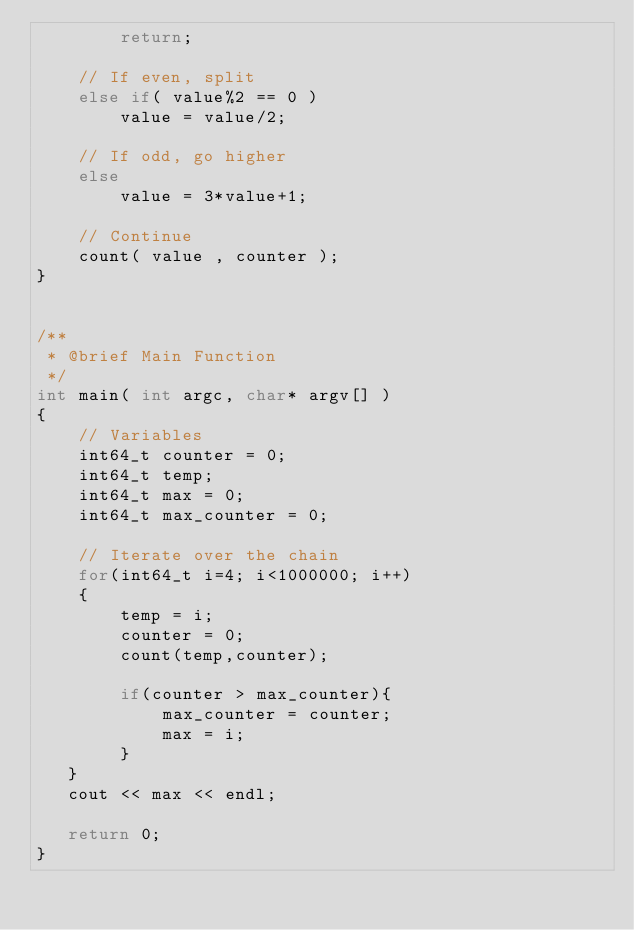<code> <loc_0><loc_0><loc_500><loc_500><_C++_>        return;

    // If even, split
    else if( value%2 == 0 )
        value = value/2;
    
    // If odd, go higher
    else
        value = 3*value+1;
    
    // Continue
    count( value , counter );
}


/** 
 * @brief Main Function
 */
int main( int argc, char* argv[] )
{
    // Variables
    int64_t counter = 0;
    int64_t temp;
    int64_t max = 0;
    int64_t max_counter = 0;

    // Iterate over the chain
    for(int64_t i=4; i<1000000; i++)
    {
        temp = i;
        counter = 0;
        count(temp,counter);
     
        if(counter > max_counter){
            max_counter = counter;
            max = i;
        }
   }
   cout << max << endl;
   
   return 0;
}

</code> 